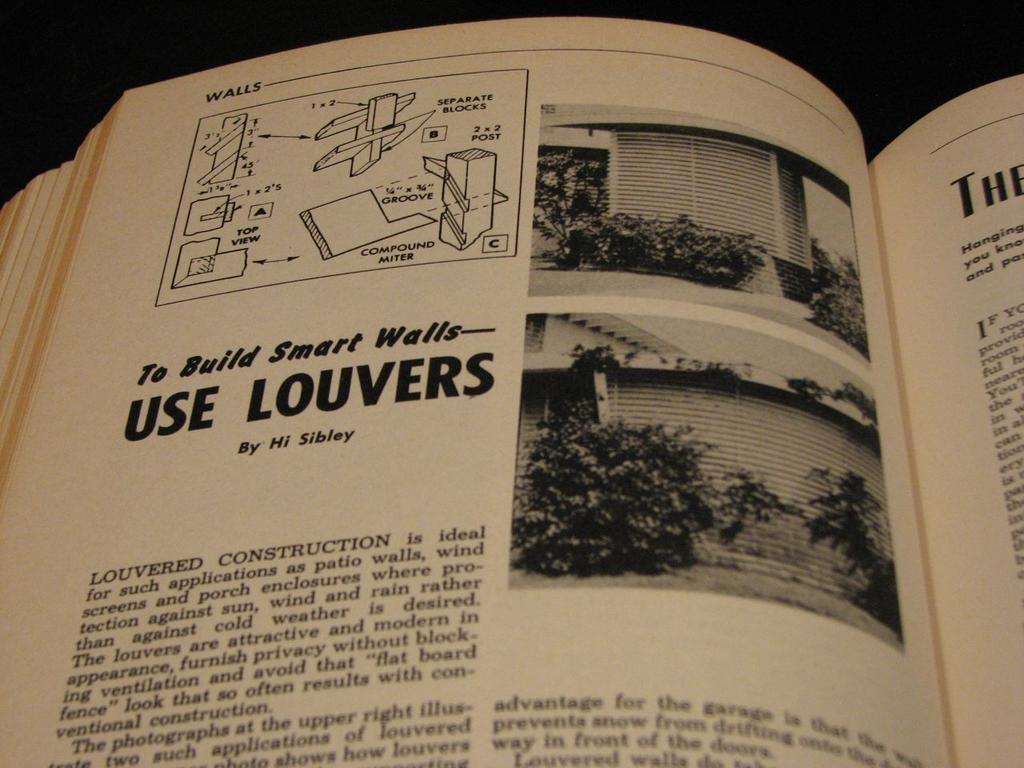<image>
Share a concise interpretation of the image provided. a book open to a page with To Build Smart Walls 